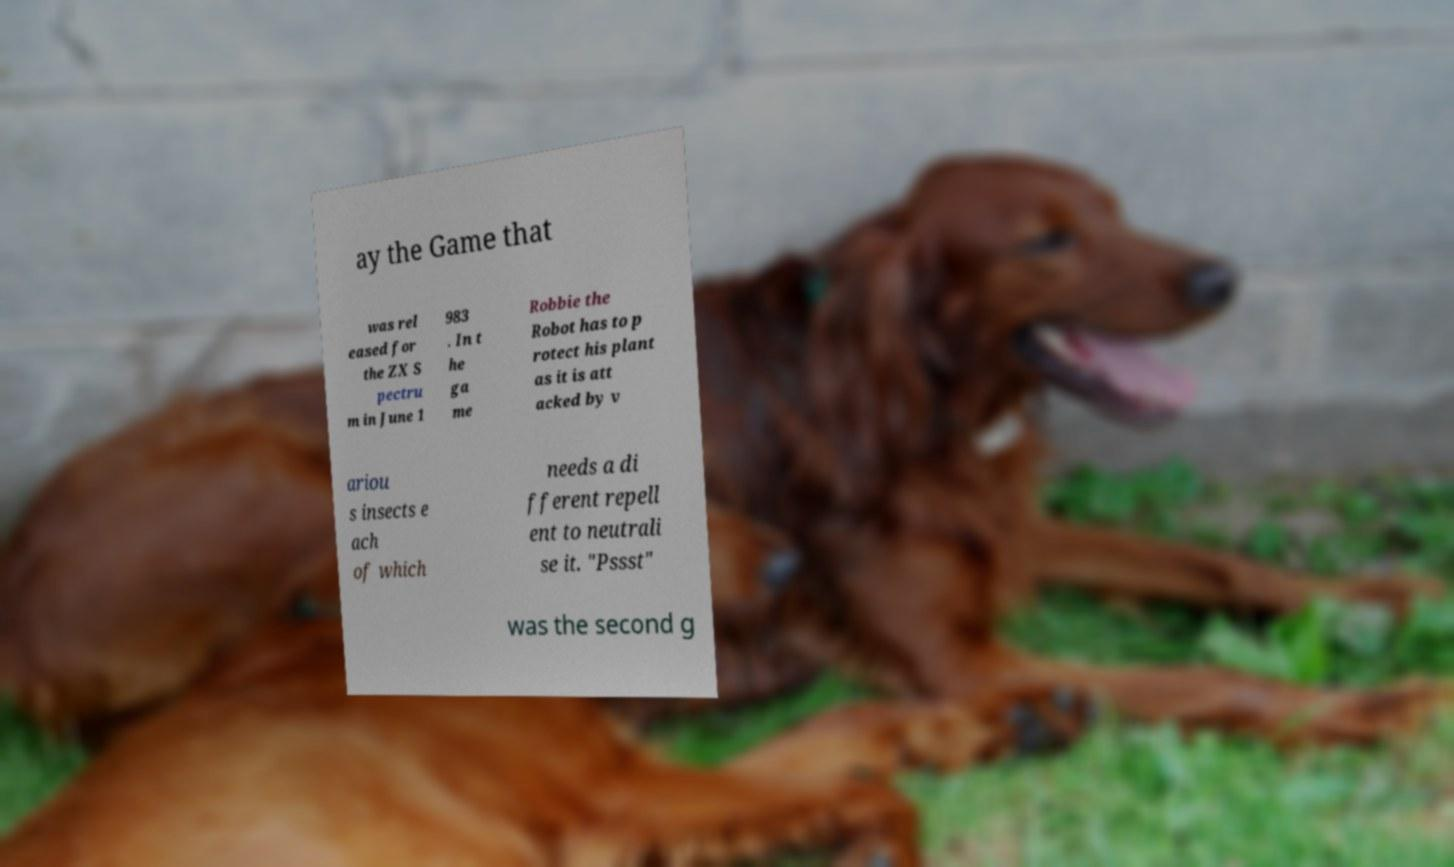Could you assist in decoding the text presented in this image and type it out clearly? ay the Game that was rel eased for the ZX S pectru m in June 1 983 . In t he ga me Robbie the Robot has to p rotect his plant as it is att acked by v ariou s insects e ach of which needs a di fferent repell ent to neutrali se it. "Pssst" was the second g 